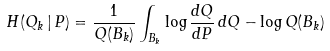Convert formula to latex. <formula><loc_0><loc_0><loc_500><loc_500>H ( Q _ { k } \, | \, P ) = \frac { 1 } { Q ( B _ { k } ) } \int _ { B _ { k } } \log \frac { d Q } { d P } \, d Q - \log Q ( B _ { k } )</formula> 